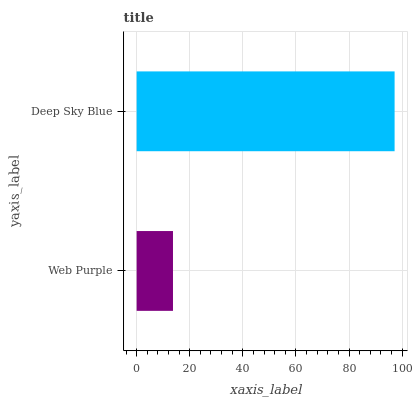Is Web Purple the minimum?
Answer yes or no. Yes. Is Deep Sky Blue the maximum?
Answer yes or no. Yes. Is Deep Sky Blue the minimum?
Answer yes or no. No. Is Deep Sky Blue greater than Web Purple?
Answer yes or no. Yes. Is Web Purple less than Deep Sky Blue?
Answer yes or no. Yes. Is Web Purple greater than Deep Sky Blue?
Answer yes or no. No. Is Deep Sky Blue less than Web Purple?
Answer yes or no. No. Is Deep Sky Blue the high median?
Answer yes or no. Yes. Is Web Purple the low median?
Answer yes or no. Yes. Is Web Purple the high median?
Answer yes or no. No. Is Deep Sky Blue the low median?
Answer yes or no. No. 